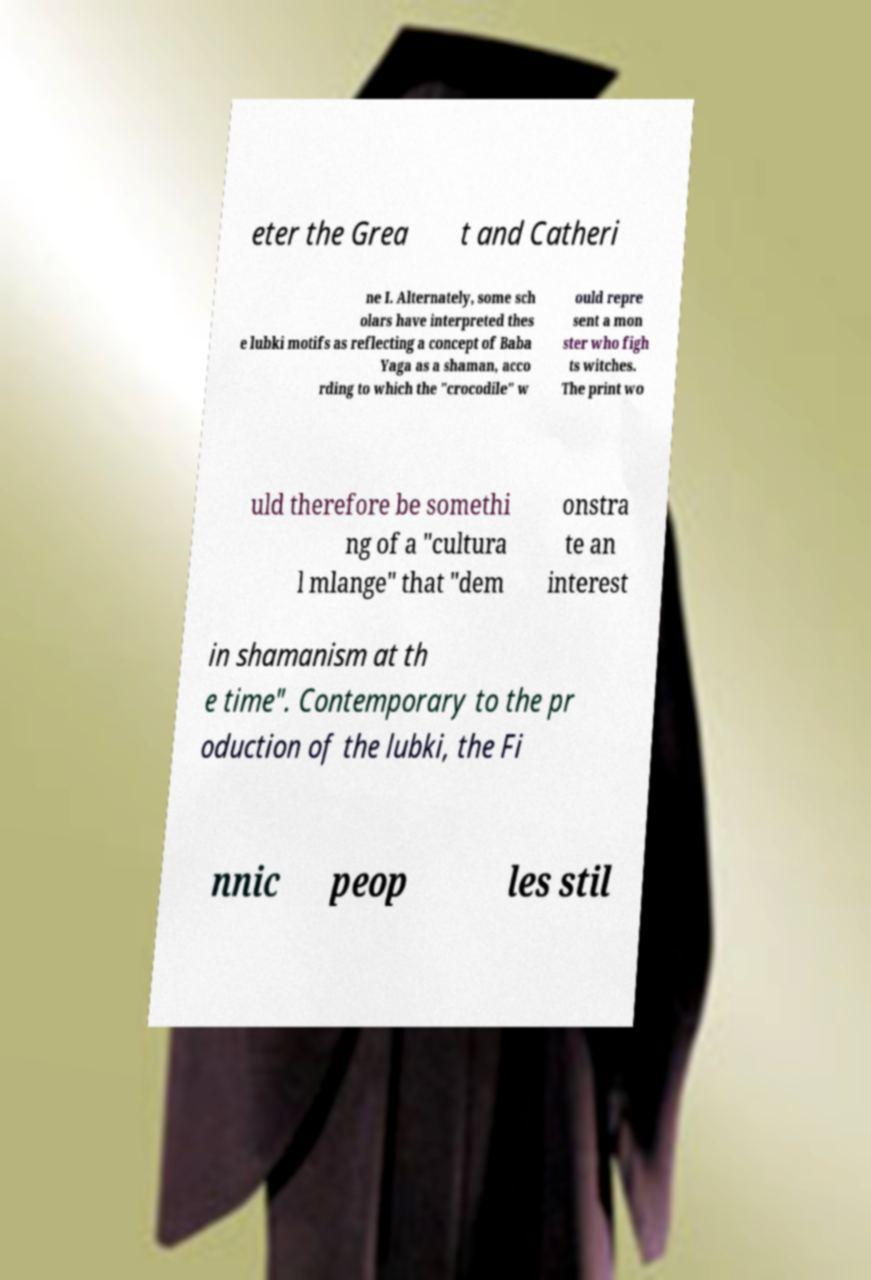What messages or text are displayed in this image? I need them in a readable, typed format. eter the Grea t and Catheri ne I. Alternately, some sch olars have interpreted thes e lubki motifs as reflecting a concept of Baba Yaga as a shaman, acco rding to which the "crocodile" w ould repre sent a mon ster who figh ts witches. The print wo uld therefore be somethi ng of a "cultura l mlange" that "dem onstra te an interest in shamanism at th e time". Contemporary to the pr oduction of the lubki, the Fi nnic peop les stil 